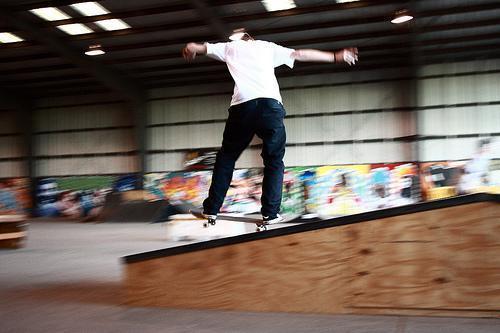How many people are visible?
Give a very brief answer. 1. 